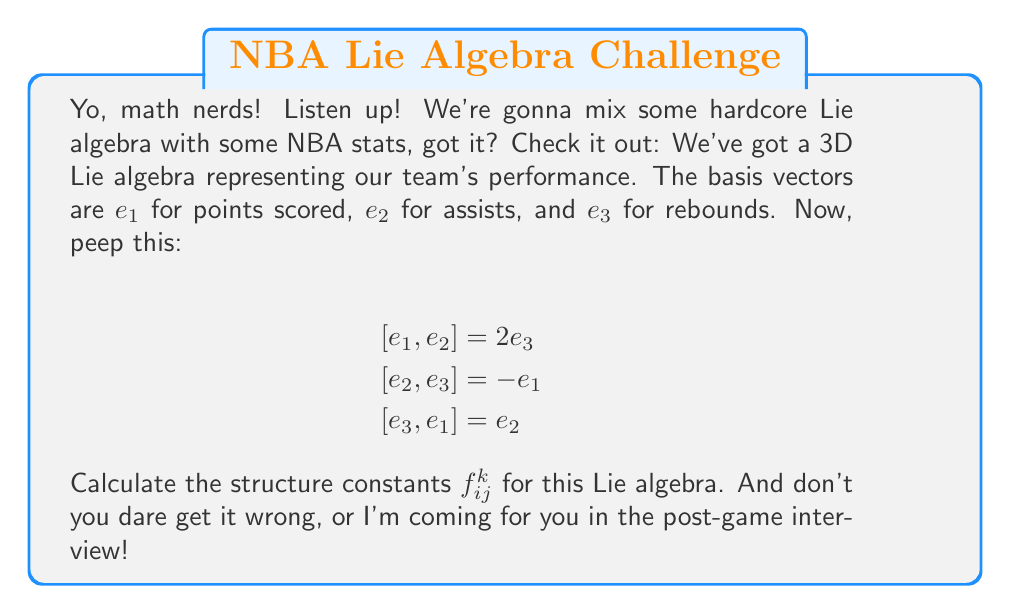Can you solve this math problem? Alright, let's break this down for you ballers out there:

1) The structure constants $f_{ij}^k$ are defined by the equation:

   $$[e_i, e_j] = \sum_k f_{ij}^k e_k$$

2) We've got three equations to work with. Let's tackle them one by one:

   For $[e_1, e_2] = 2e_3$:
   This means $f_{12}^3 = 2$, and all other $f_{12}^k = 0$

   For $[e_2, e_3] = -e_1$:
   This means $f_{23}^1 = -1$, and all other $f_{23}^k = 0$

   For $[e_3, e_1] = e_2$:
   This means $f_{31}^2 = 1$, and all other $f_{31}^k = 0$

3) Now, we need to remember that the structure constants are antisymmetric in the lower indices:

   $$f_{ij}^k = -f_{ji}^k$$

   This gives us:
   $f_{21}^3 = -2$
   $f_{32}^1 = 1$
   $f_{13}^2 = -1$

4) All other structure constants not mentioned are zero.

So, we've got our full set of non-zero structure constants:

$f_{12}^3 = 2$, $f_{21}^3 = -2$
$f_{23}^1 = -1$, $f_{32}^1 = 1$
$f_{31}^2 = 1$, $f_{13}^2 = -1$

And that's how you dominate in Lie algebras like I dominate on the court!
Answer: The non-zero structure constants are:
$$f_{12}^3 = 2, f_{21}^3 = -2$$
$$f_{23}^1 = -1, f_{32}^1 = 1$$
$$f_{31}^2 = 1, f_{13}^2 = -1$$
All other $f_{ij}^k = 0$ 